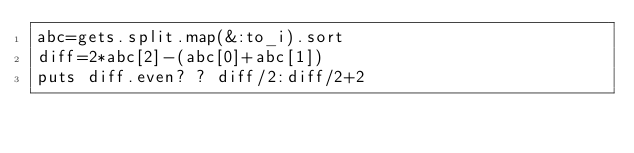Convert code to text. <code><loc_0><loc_0><loc_500><loc_500><_Ruby_>abc=gets.split.map(&:to_i).sort
diff=2*abc[2]-(abc[0]+abc[1])
puts diff.even? ? diff/2:diff/2+2
</code> 